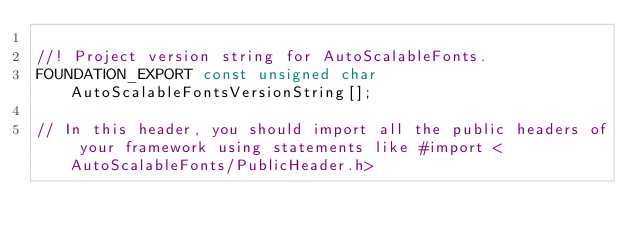<code> <loc_0><loc_0><loc_500><loc_500><_C_>
//! Project version string for AutoScalableFonts.
FOUNDATION_EXPORT const unsigned char AutoScalableFontsVersionString[];

// In this header, you should import all the public headers of your framework using statements like #import <AutoScalableFonts/PublicHeader.h>


</code> 